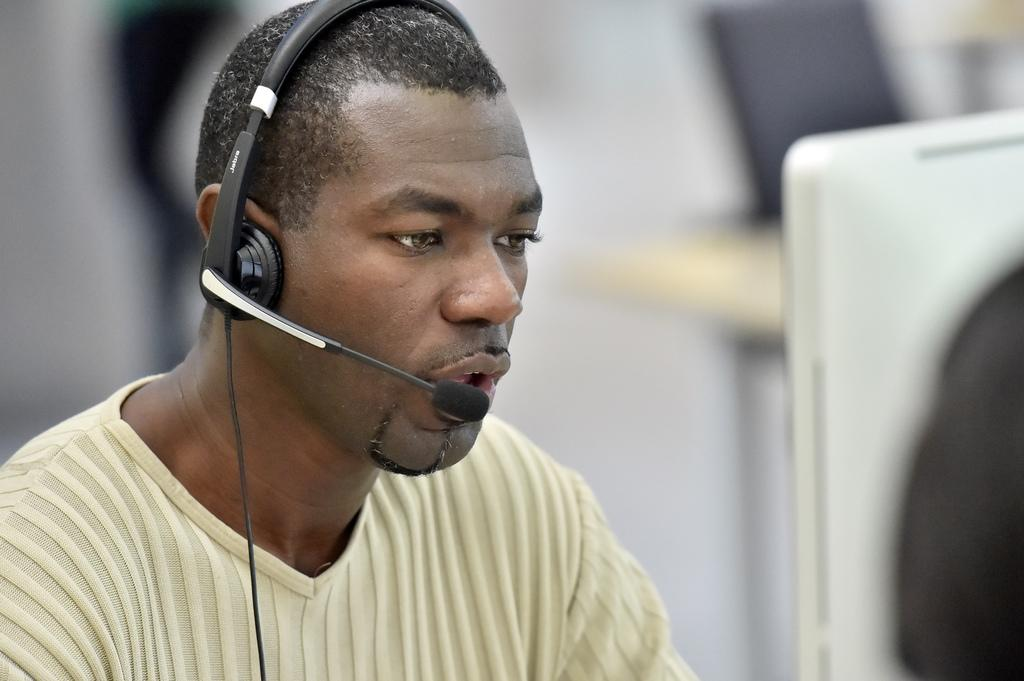What is the main subject of the image? There is a person in the image. What is the person wearing in the image? The person is wearing a microphone. How does the person turn a profit in the image? There is no information about the person turning a profit in the image. 